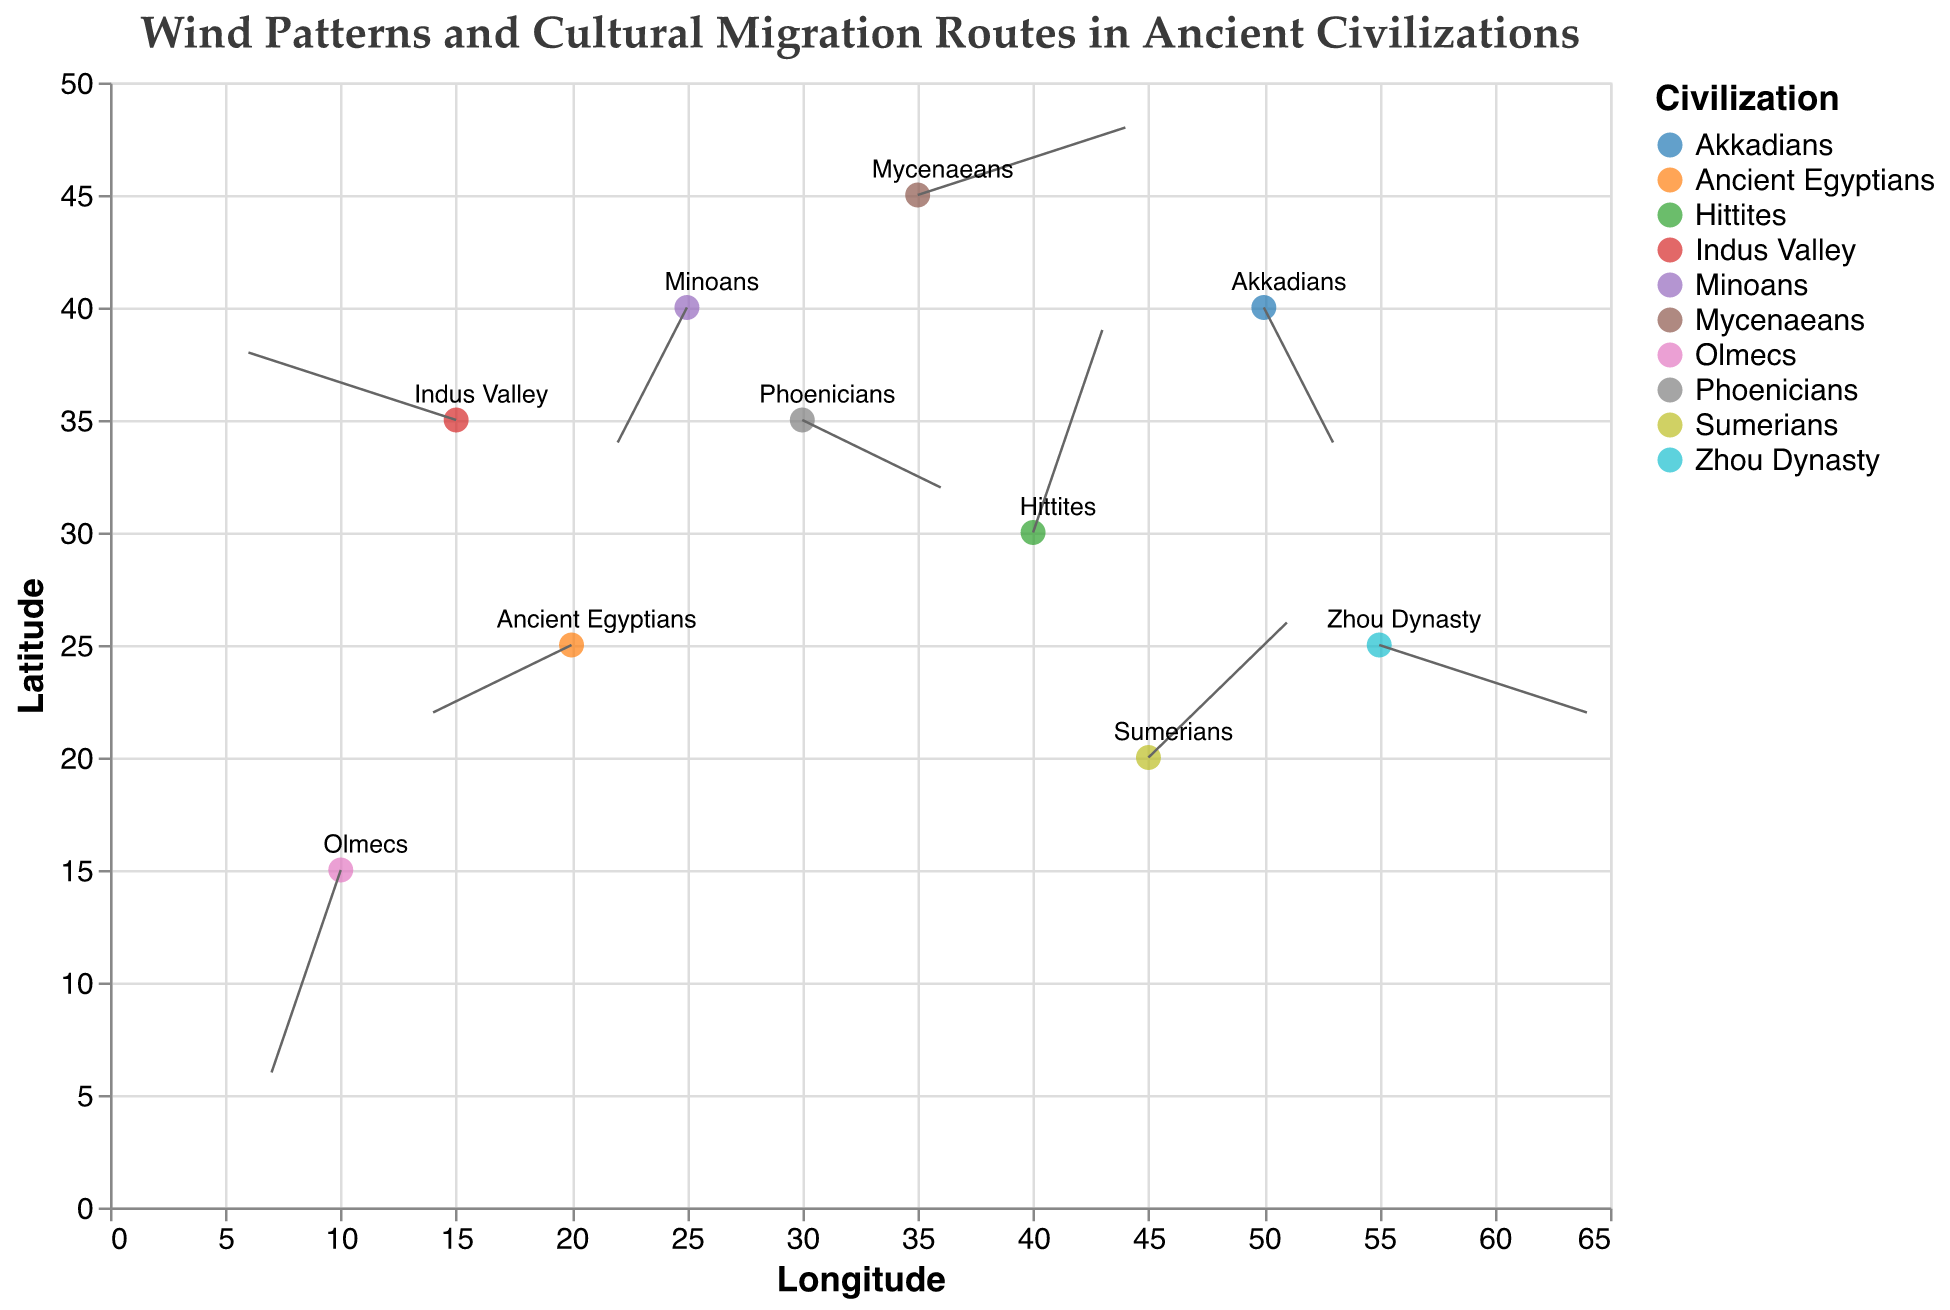Which civilization is represented at the highest latitude on the plot? Locate the highest Y coordinate on the plot. The Mycenaeans are at Y=45, which is the highest.
Answer: Mycenaeans Which civilization migrated southward according to the vector direction? Check the vectors with negative V values (indicating a move towards smaller Y coordinates). The civilizations with negative V values are the Phoenicians, Minoans, Akkadians, and Olmecs.
Answer: Phoenicians, Minoans, Akkadians, Olmecs What period did the Sumerians migrate in according to the plot? Use the tooltip information to find details about the Sumerians. The tooltip shows "Migration Period: 4500 BCE" for the Sumerians.
Answer: 4500 BCE Which civilization has a positive vector both in the X and the Y directions? Look for vectors where both U and V are positive. The Sumerians have U=2 and V=2.
Answer: Sumerians Compare the vector magnitudes of the Zhou Dynasty and the Hittites. Which one has the greater magnitude? Calculate the magnitudes using the formula sqrt(U^2 + V^2). The Zhou Dynasty has U=3 and V=-1, magnitude is sqrt(3^2 + (-1)^2) = sqrt(10). The Hittites have U=1 and V=3, magnitude is sqrt(1^2 + 3^2) = sqrt(10). Both have the same magnitude.
Answer: Equal Which direction does the Indus Valley civilization's vector point to? The Indus Valley has U=-3 and V=1, pointing towards the left (negative x) and up (positive y).
Answer: Left and up What is the longitude and latitude of the starting point for the Olmecs migration? Find the data point labeled 'Olmecs'. The coordinates are X=10 and Y=15.
Answer: 10, 15 Which civilization had an eastward migration? Check for vectors with positive U values (eastward). The civilizations with positive U values are the Phoenicians, Mycenaeans, Hittites, Sumerians, Akkadians, and Zhou Dynasty.
Answer: Phoenicians, Mycenaeans, Hittites, Sumerians, Akkadians, Zhou Dynasty Compare the net vector direction for the civilizations starting at latitudes between 30 and 35. Which civilization’s migration moved the most southward? Analyze the V values of civilizations with starting Y values between 30 and 35. The Phoenicians (Y=35, V=-1), Hittites (Y=30, V=3), Indus Valley (Y=35, V=1). The Phoenicians moved most southward with V=-1.
Answer: Phoenicians What is the approximate combined magnitude of the migration vectors for the Phoenicians and Akkadians? Calculate the magnitudes and sum them. Phoenicians have U=2, V=-1, magnitude=sqrt(2^2 + (-1)^2)=sqrt(5). Akkadians have U=1, V=-2, magnitude=sqrt(1^2 + (-2)^2)=sqrt(5). Combined magnitude is sqrt(5) + sqrt(5) = 2sqrt(5).
Answer: 2√5 